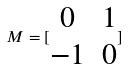<formula> <loc_0><loc_0><loc_500><loc_500>M = [ \begin{matrix} 0 & 1 \\ - 1 & 0 \end{matrix} ]</formula> 